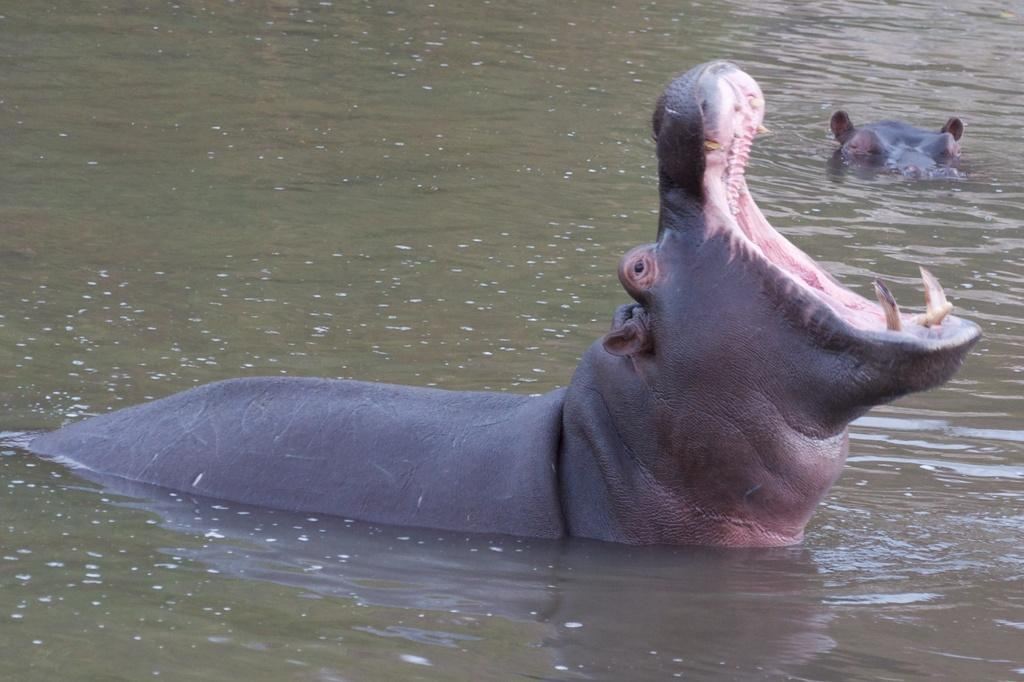How many animals are present in the image? There are two animals in the image. Where are the animals located? The animals are in the water. Can you tell me how many marbles are floating in the water with the animals? There are no marbles present in the image; it only features two animals in the water. 